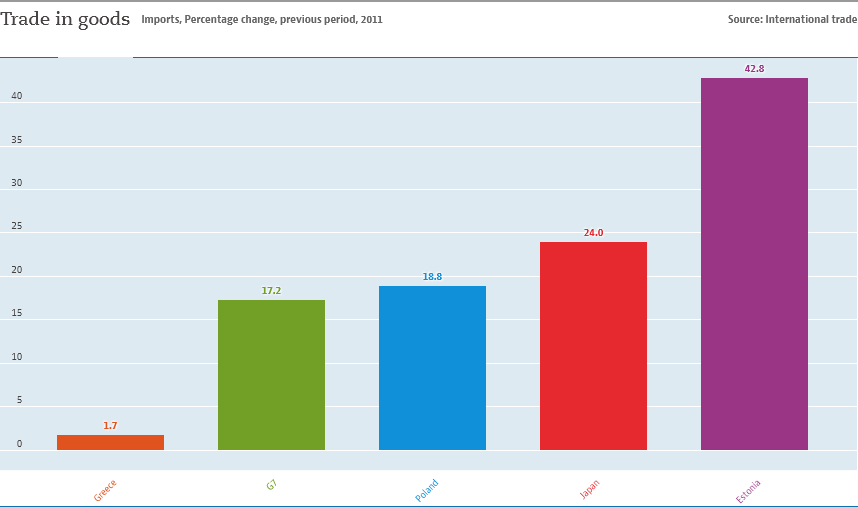Mention a couple of crucial points in this snapshot. The sum of all the bars above 20 is 66.8. The value of the green bar is 17.2. 